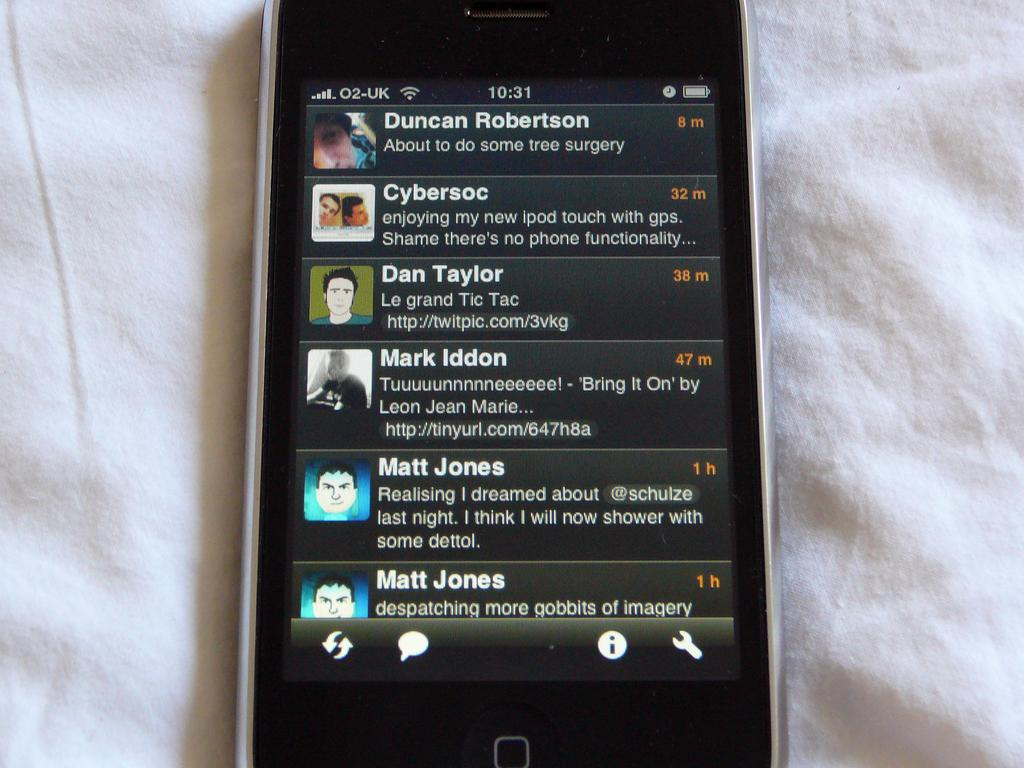<image>
Provide a brief description of the given image. A cell phone shows some messages, including two by Matt Jones. 